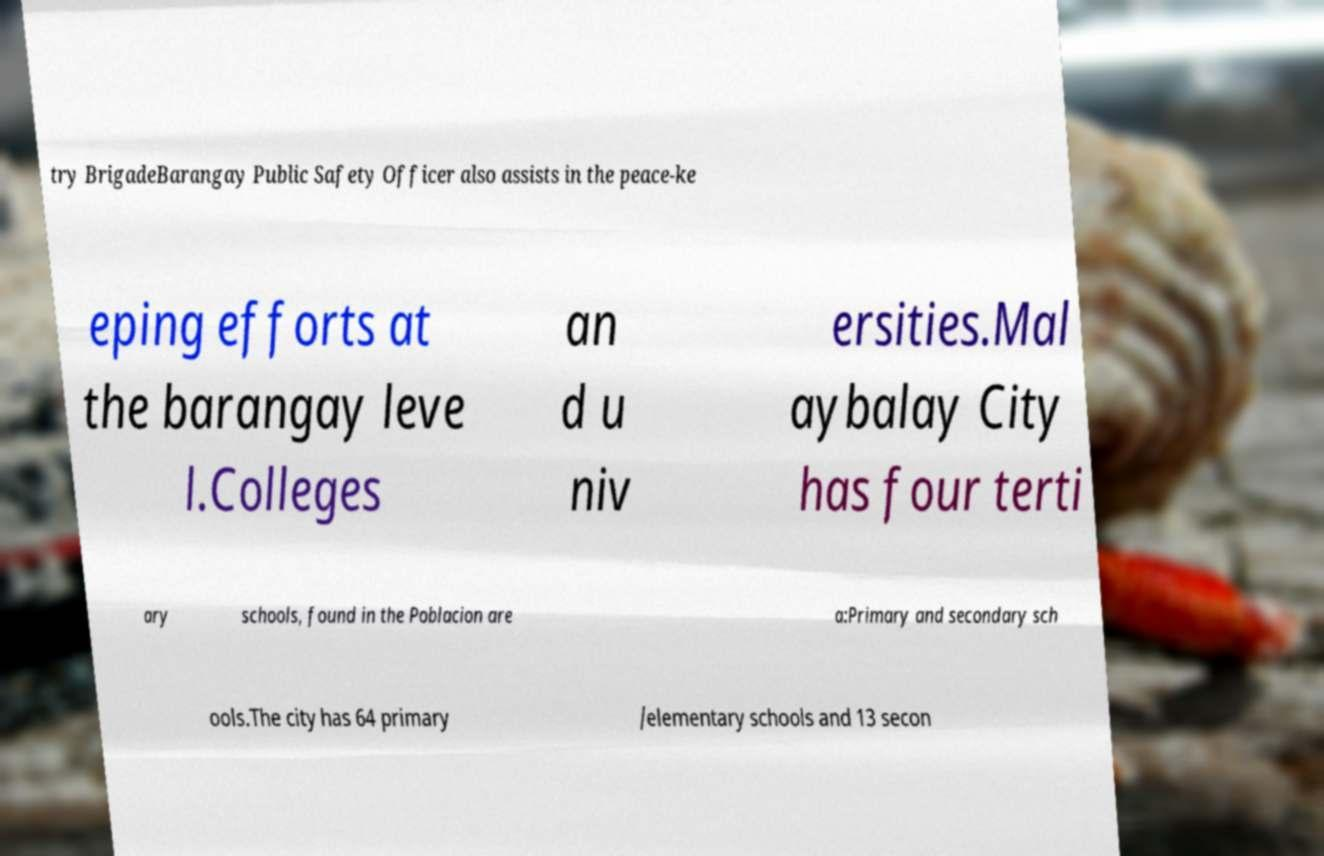Please read and relay the text visible in this image. What does it say? try BrigadeBarangay Public Safety Officer also assists in the peace-ke eping efforts at the barangay leve l.Colleges an d u niv ersities.Mal aybalay City has four terti ary schools, found in the Poblacion are a:Primary and secondary sch ools.The city has 64 primary /elementary schools and 13 secon 